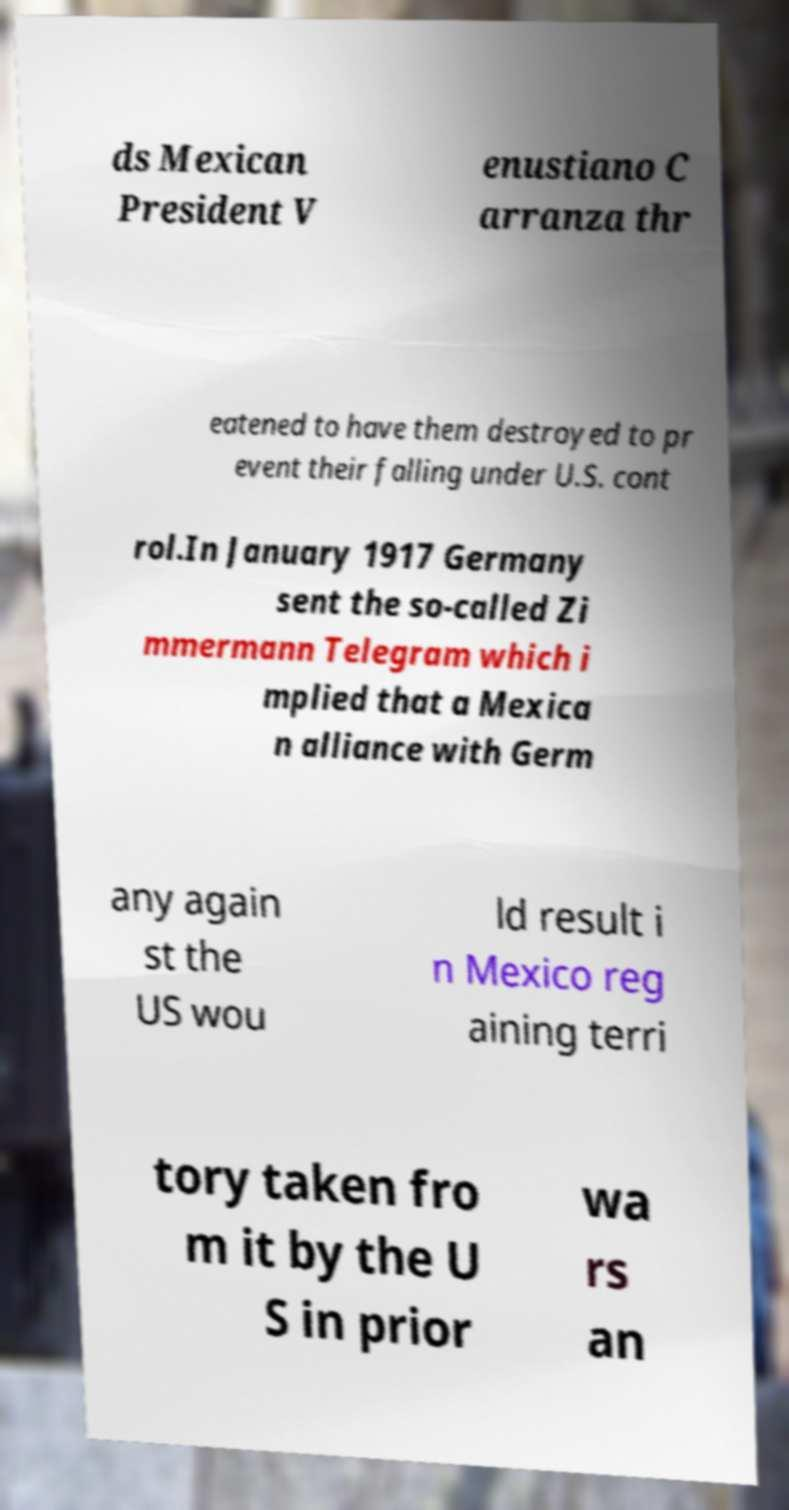I need the written content from this picture converted into text. Can you do that? ds Mexican President V enustiano C arranza thr eatened to have them destroyed to pr event their falling under U.S. cont rol.In January 1917 Germany sent the so-called Zi mmermann Telegram which i mplied that a Mexica n alliance with Germ any again st the US wou ld result i n Mexico reg aining terri tory taken fro m it by the U S in prior wa rs an 